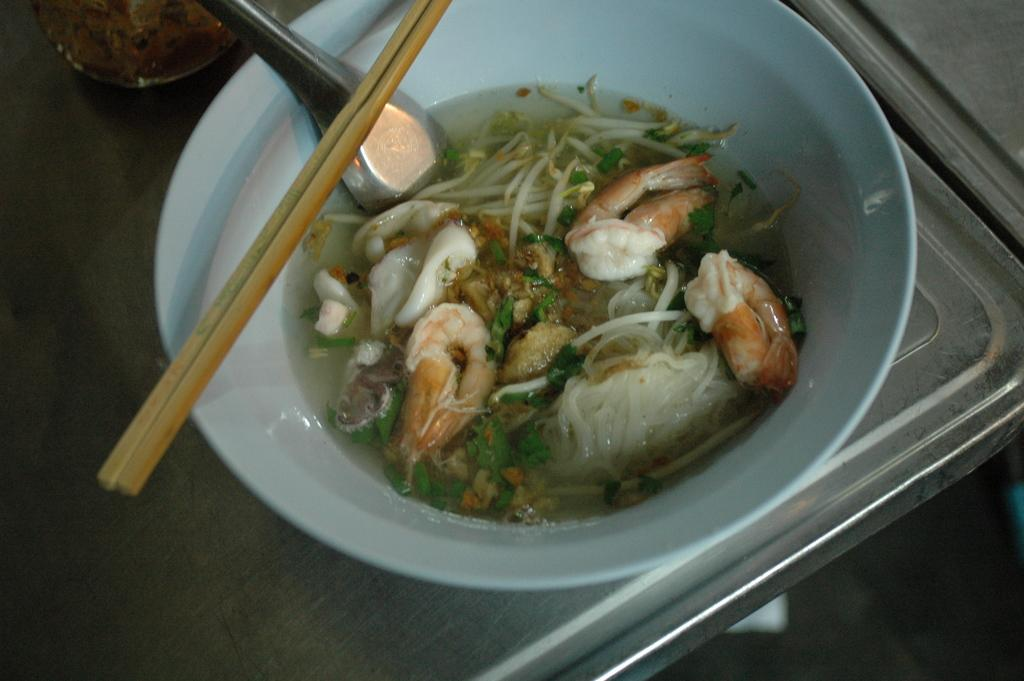What type of food items can be seen in the image? There are food items in a bowl in the image. What utensils are visible in the image? Spoons and chopsticks are present in the image. Where are the food items and utensils placed? The items are placed on a table. What type of whistle can be heard in the image? There is no whistle present in the image, so it is not possible to determine if any whistle can be heard. 